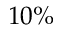<formula> <loc_0><loc_0><loc_500><loc_500>1 0 \%</formula> 